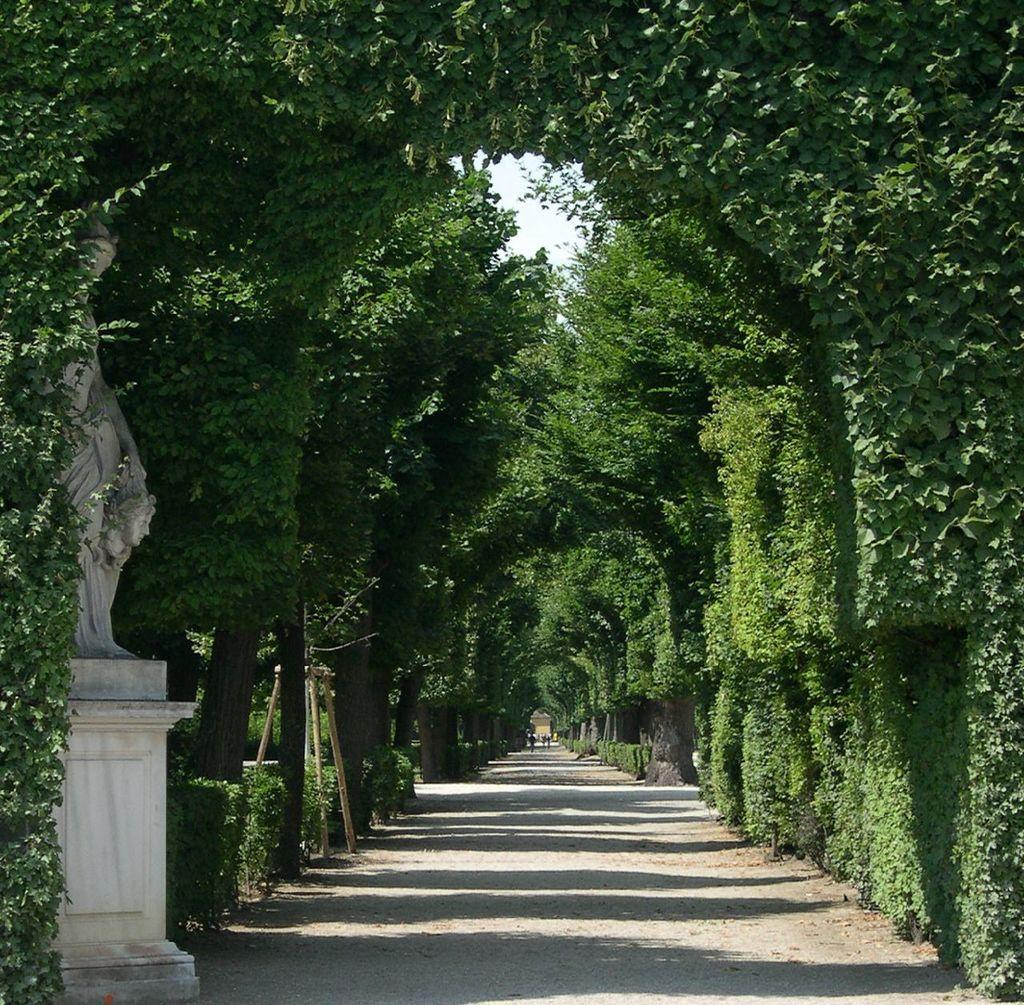What is the main feature in the center of the image? There is a road in the center of the image. What type of vegetation can be seen on both sides of the road? There are trees on both sides of the image. What is located on the left side of the image? There is a statue on the left side of the image. Can you see any fairies flying around the statue in the image? There are no fairies present in the image. What type of chin does the statue have in the image? The image does not show the statue's chin, as it only depicts the statue from the side. 